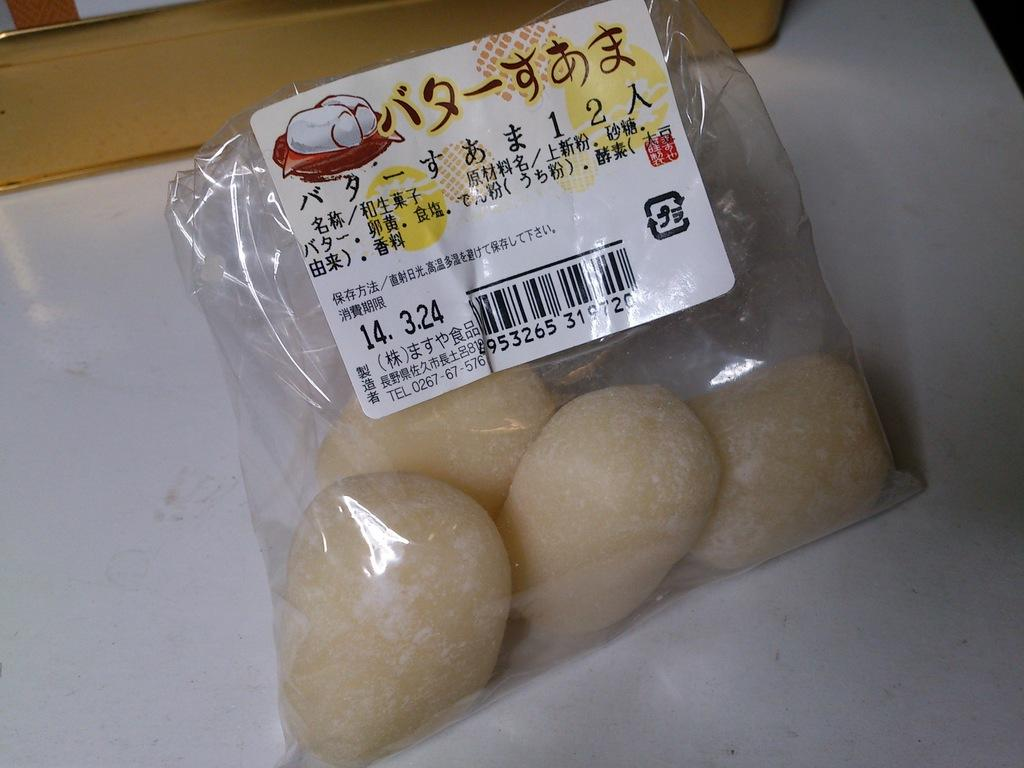What is inside the cover that is visible in the image? There is food inside a cover in the image. Where is the cover placed in the image? The cover is placed on a table in the image. What is written or displayed on the cover? There is a sticker with text on the cover. What additional information can be found on the sticker? There is a bar code on the sticker. What type of crown is worn by the food in the image? There is no crown present in the image; it features food inside a cover with a sticker on it. 